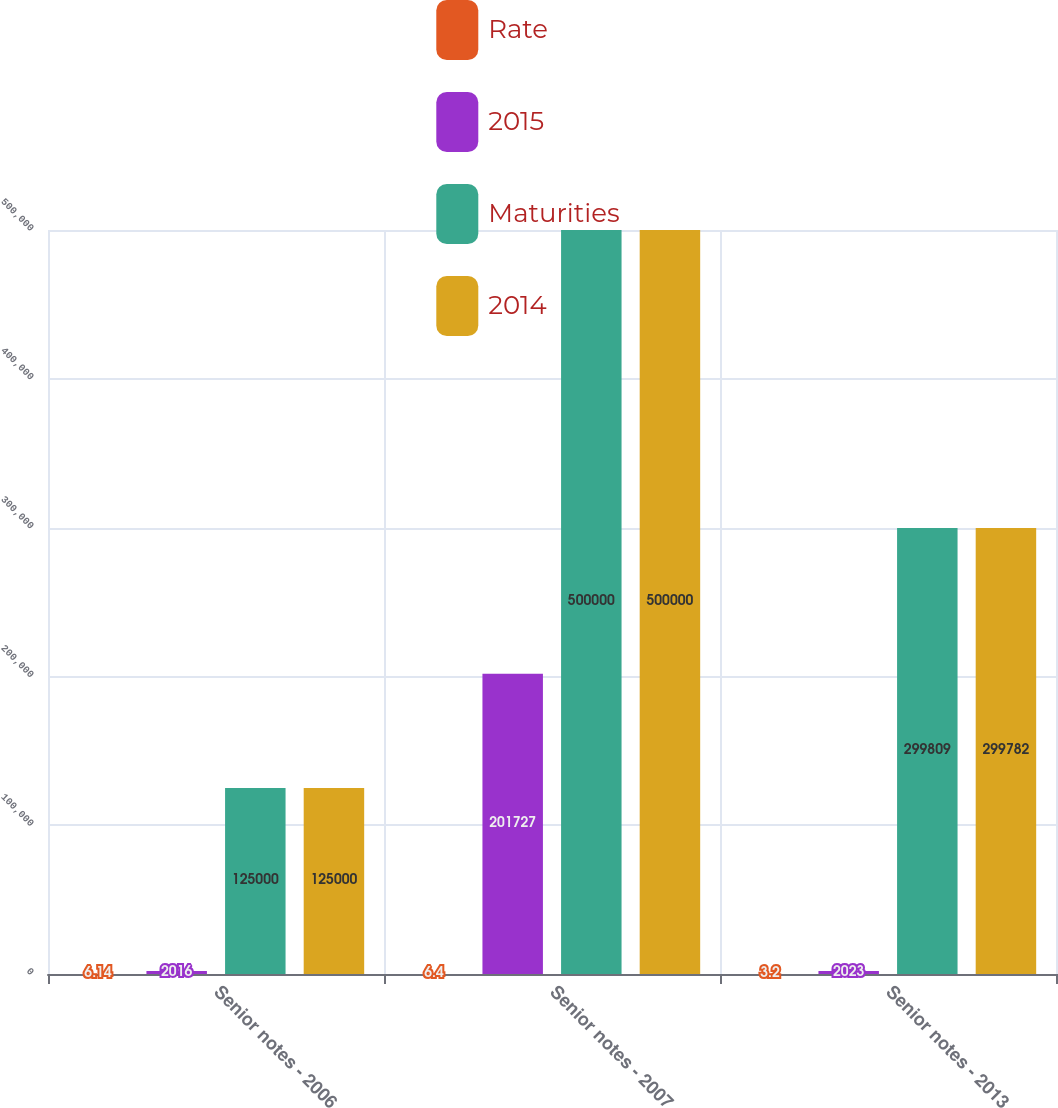Convert chart. <chart><loc_0><loc_0><loc_500><loc_500><stacked_bar_chart><ecel><fcel>Senior notes - 2006<fcel>Senior notes - 2007<fcel>Senior notes - 2013<nl><fcel>Rate<fcel>6.14<fcel>6.4<fcel>3.2<nl><fcel>2015<fcel>2016<fcel>201727<fcel>2023<nl><fcel>Maturities<fcel>125000<fcel>500000<fcel>299809<nl><fcel>2014<fcel>125000<fcel>500000<fcel>299782<nl></chart> 